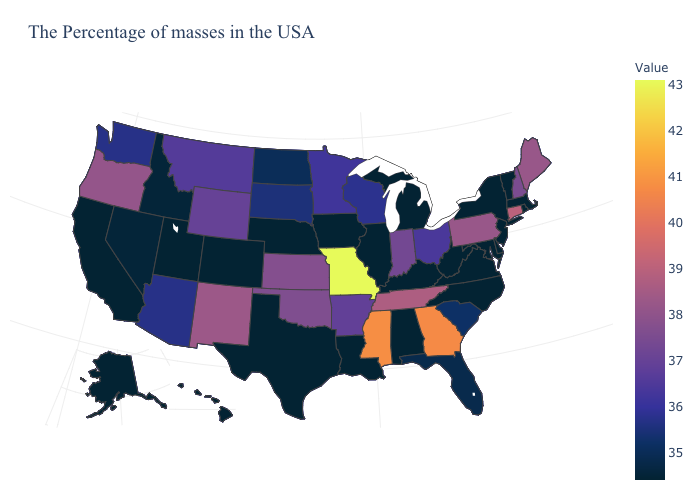Does the map have missing data?
Be succinct. No. Is the legend a continuous bar?
Give a very brief answer. Yes. Among the states that border Nevada , which have the highest value?
Answer briefly. Oregon. Does Virginia have the highest value in the South?
Keep it brief. No. Does Arkansas have a higher value than Iowa?
Quick response, please. Yes. Does Hawaii have a lower value than Arizona?
Answer briefly. Yes. 